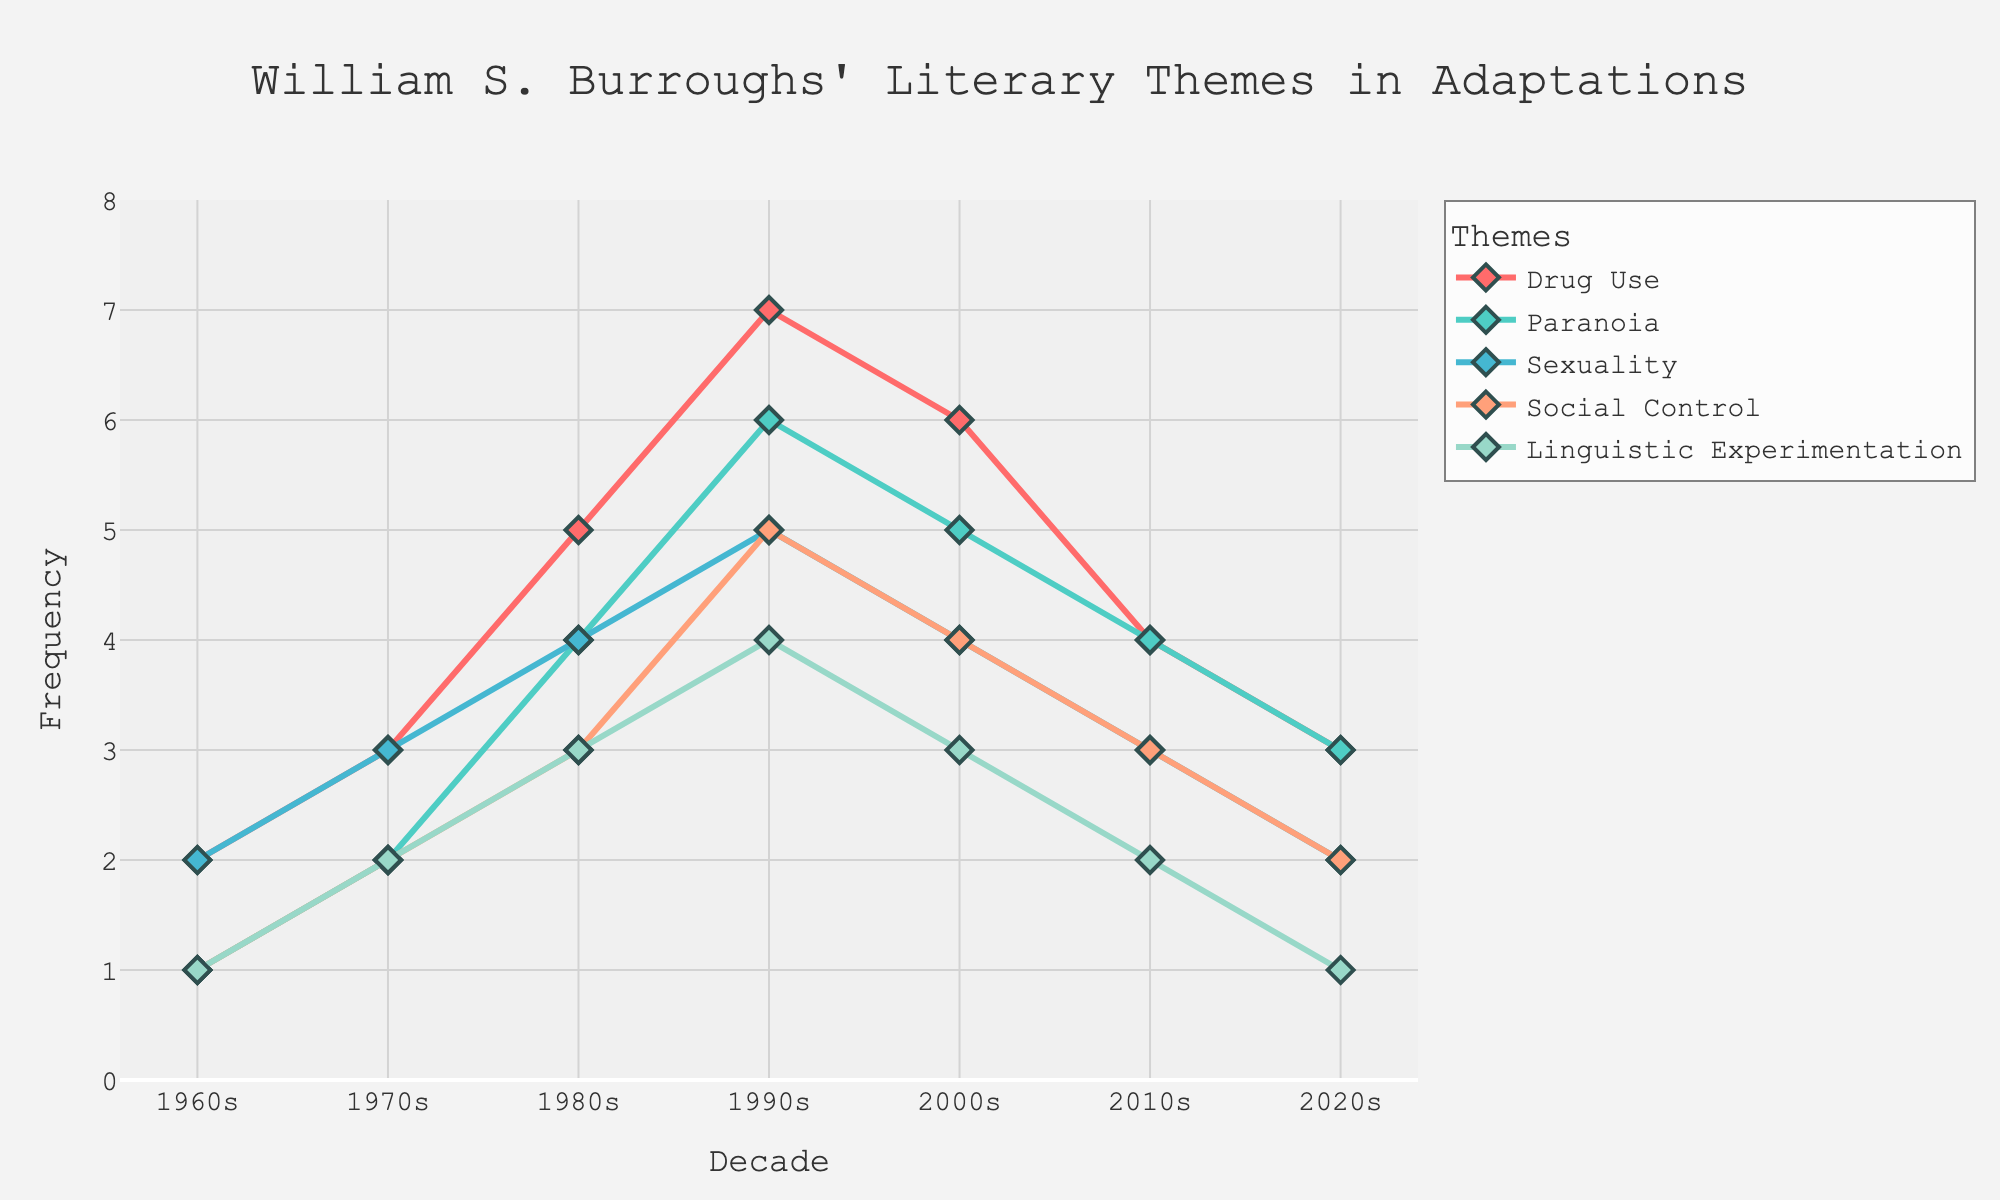Which theme had the highest frequency in the 1990s? Look at the figure for the 1990s and identify the highest point among all the themes. Drug Use has the highest value of 7 in the 1990s.
Answer: Drug Use What is the overall trend of the Paranoia theme from the 1960s to the 2020s? Analyze the line for the Paranoia theme across all decades. Initially, it increases from the 1960s and peaks in the 1990s, then gradually decreases until the 2020s.
Answer: Increasing until 1990s, then decreasing Which two themes have equal frequency values in the 2010s? Look at the frequency values for each theme in the 2010s and find pairs with equal values. Both Paranoia and Sexuality have a frequency of 4 in the 2010s.
Answer: Paranoia and Sexuality By how much did the frequency of Drug Use change between the 1990s and the 2000s? Calculate the difference in frequency of Drug Use between the 1990s and the 2000s. In the 1990s, it is 7 and in the 2000s, it is 6, so the change is 7 - 6 = 1.
Answer: 1 Which theme showed a peak frequency in the 1980s but declined thereafter? Identify the themes that have their highest value in the 1980s and check if this value declines in subsequent decades. Linguistic Experimentation reaches 3 in the 1980s and then drops.
Answer: Linguistic Experimentation Which theme's frequency was consistently higher than 2 from the 1970s to the 1990s? Check the frequency values of each theme from the 1970s to the 1990s and see which one remains above 2. Drug Use is consistently above 2 during these decades.
Answer: Drug Use How did the frequency of Social Control change from the 1960s to the 2000s? Examine the Social Control values across these decades: growing from 1 in the 1960s to a peak of 5 in the 1990s, then decreasing to 4 by the 2000s.
Answer: Increased then decreased What is the total frequency of Linguistic Experimentation across all decades? Sum up the values of Linguistic Experimentation across all decades: 1 + 2 + 3 + 4 + 3 + 2 + 1 = 16.
Answer: 16 Among all the themes, which theme's frequency increased the most between the 1960s and 1990s? Calculate the difference in frequency between the 1960s and 1990s for all themes. Drug Use increased from 2 to 7, which is the largest gain of 5.
Answer: Drug Use Comparing the 1980s and 2020s, which theme showed the greatest drop in frequency? Find the frequency value for each theme in the 1980s and 2020s, and calculate the difference to find the largest decrease. Sexuality drops from 4 to 2, a difference of 2.
Answer: Sexuality 